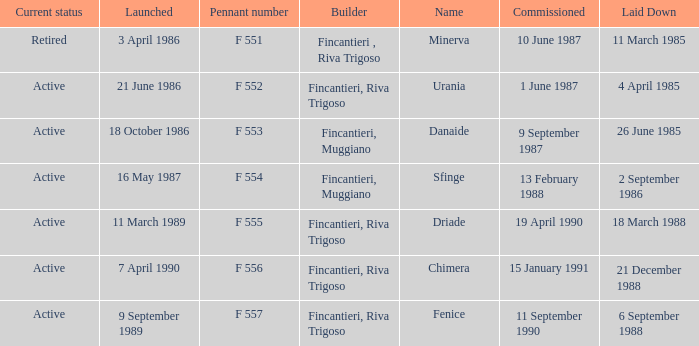Which launch date involved the Driade? 11 March 1989. 